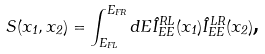<formula> <loc_0><loc_0><loc_500><loc_500>S ( x _ { 1 } , x _ { 2 } ) = \int _ { E _ { F L } } ^ { E _ { F R } } d E \hat { I } ^ { R L } _ { E E } ( x _ { 1 } ) \hat { I } ^ { L R } _ { E E } ( x _ { 2 } ) \text {,}</formula> 